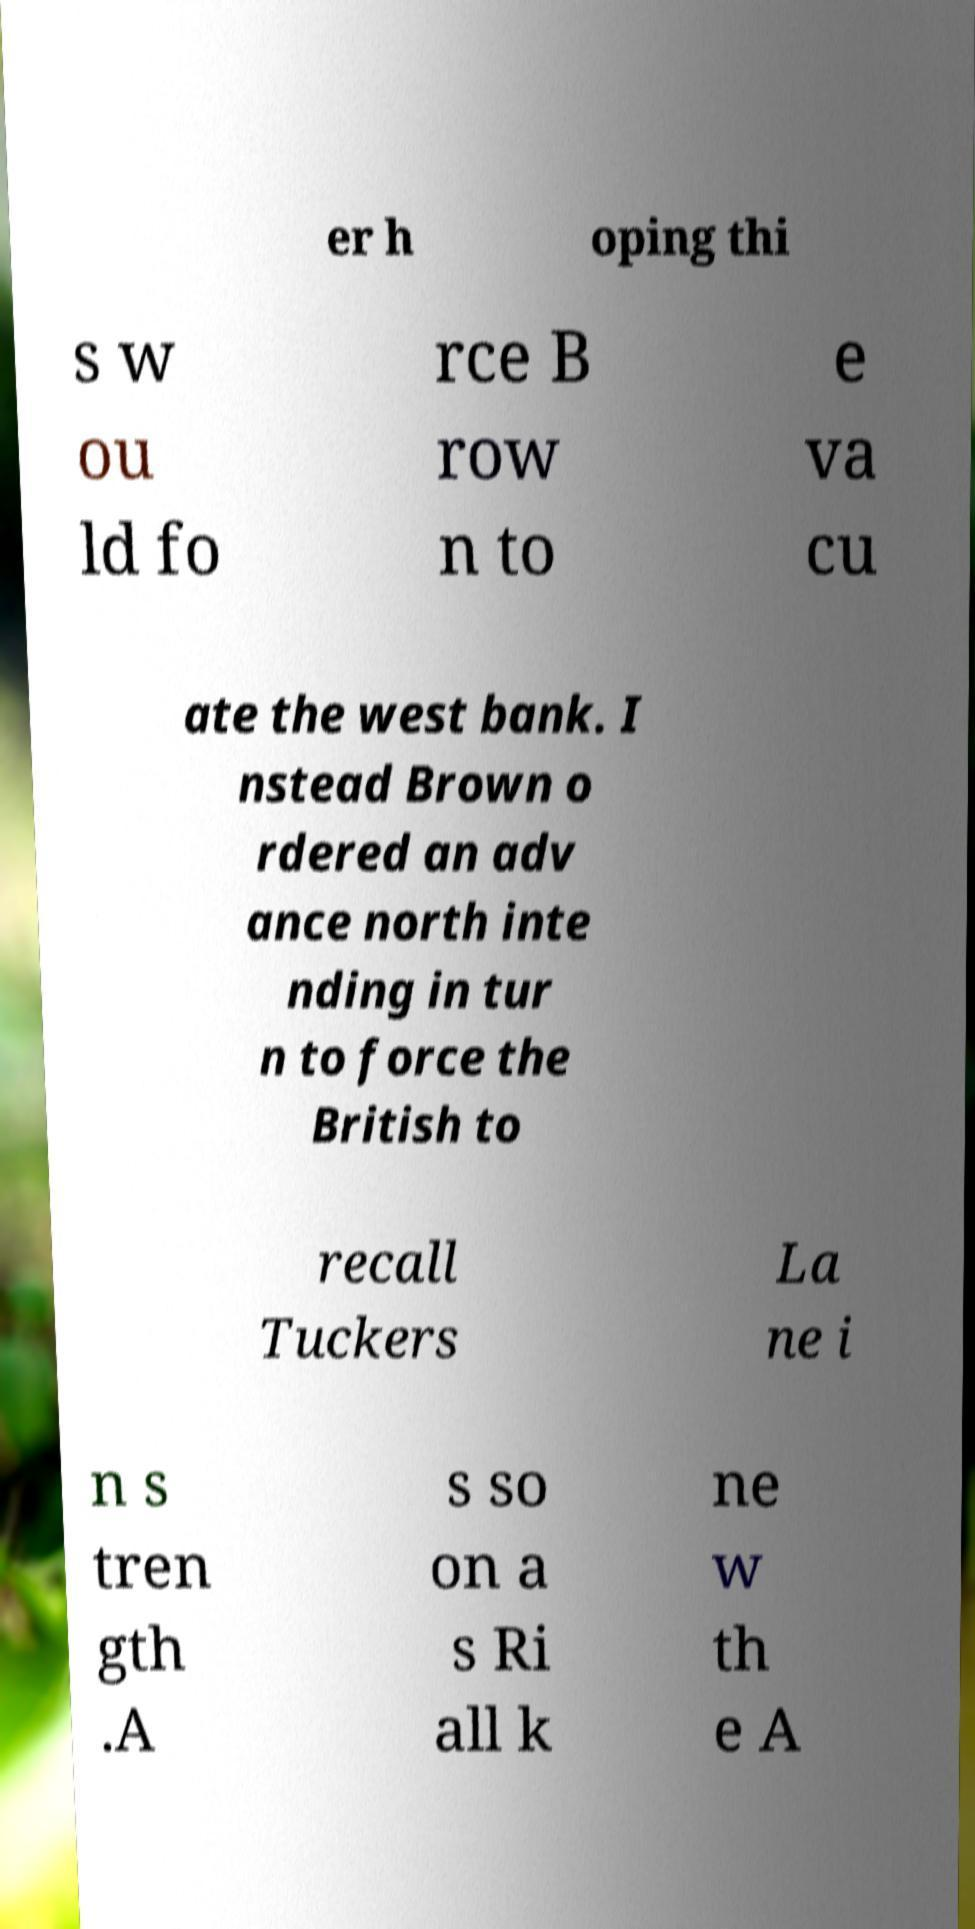Please read and relay the text visible in this image. What does it say? er h oping thi s w ou ld fo rce B row n to e va cu ate the west bank. I nstead Brown o rdered an adv ance north inte nding in tur n to force the British to recall Tuckers La ne i n s tren gth .A s so on a s Ri all k ne w th e A 